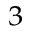<formula> <loc_0><loc_0><loc_500><loc_500>^ { 3 }</formula> 